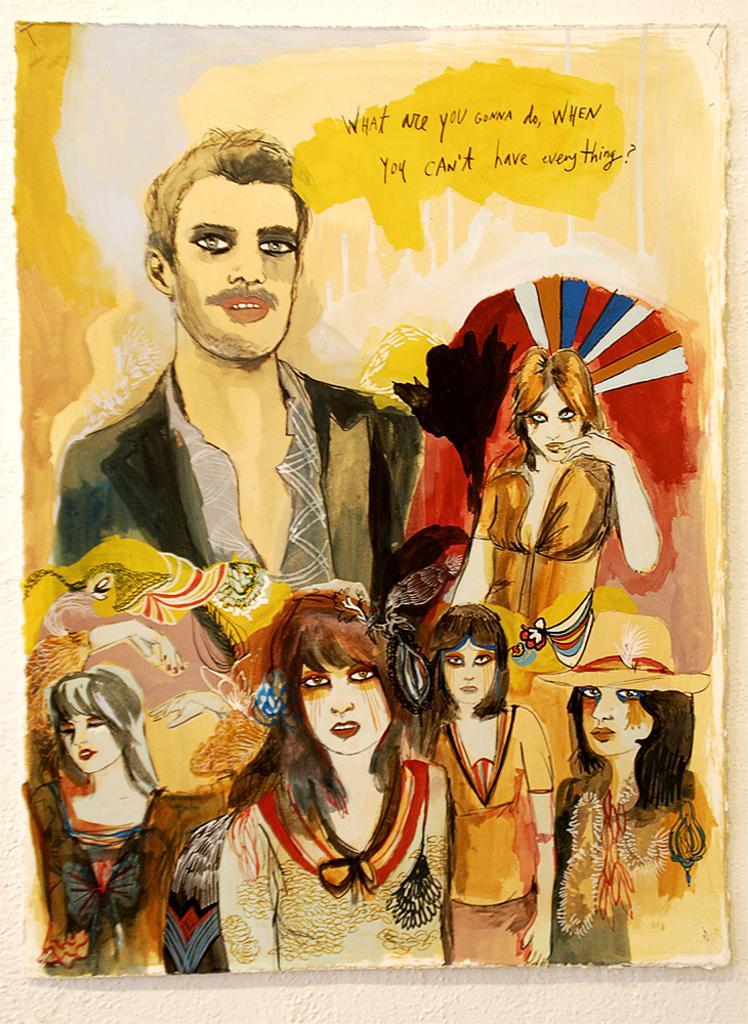Describe this image in one or two sentences. This picture is consists of a poster, in which there are people those who are wearing costumes in it. 